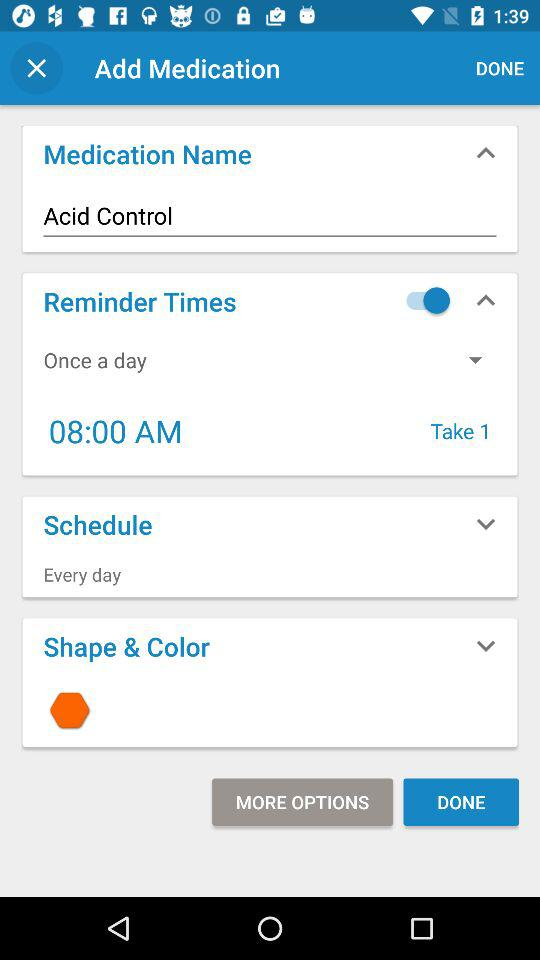What's the medication name? The medication name is Acid Control. 